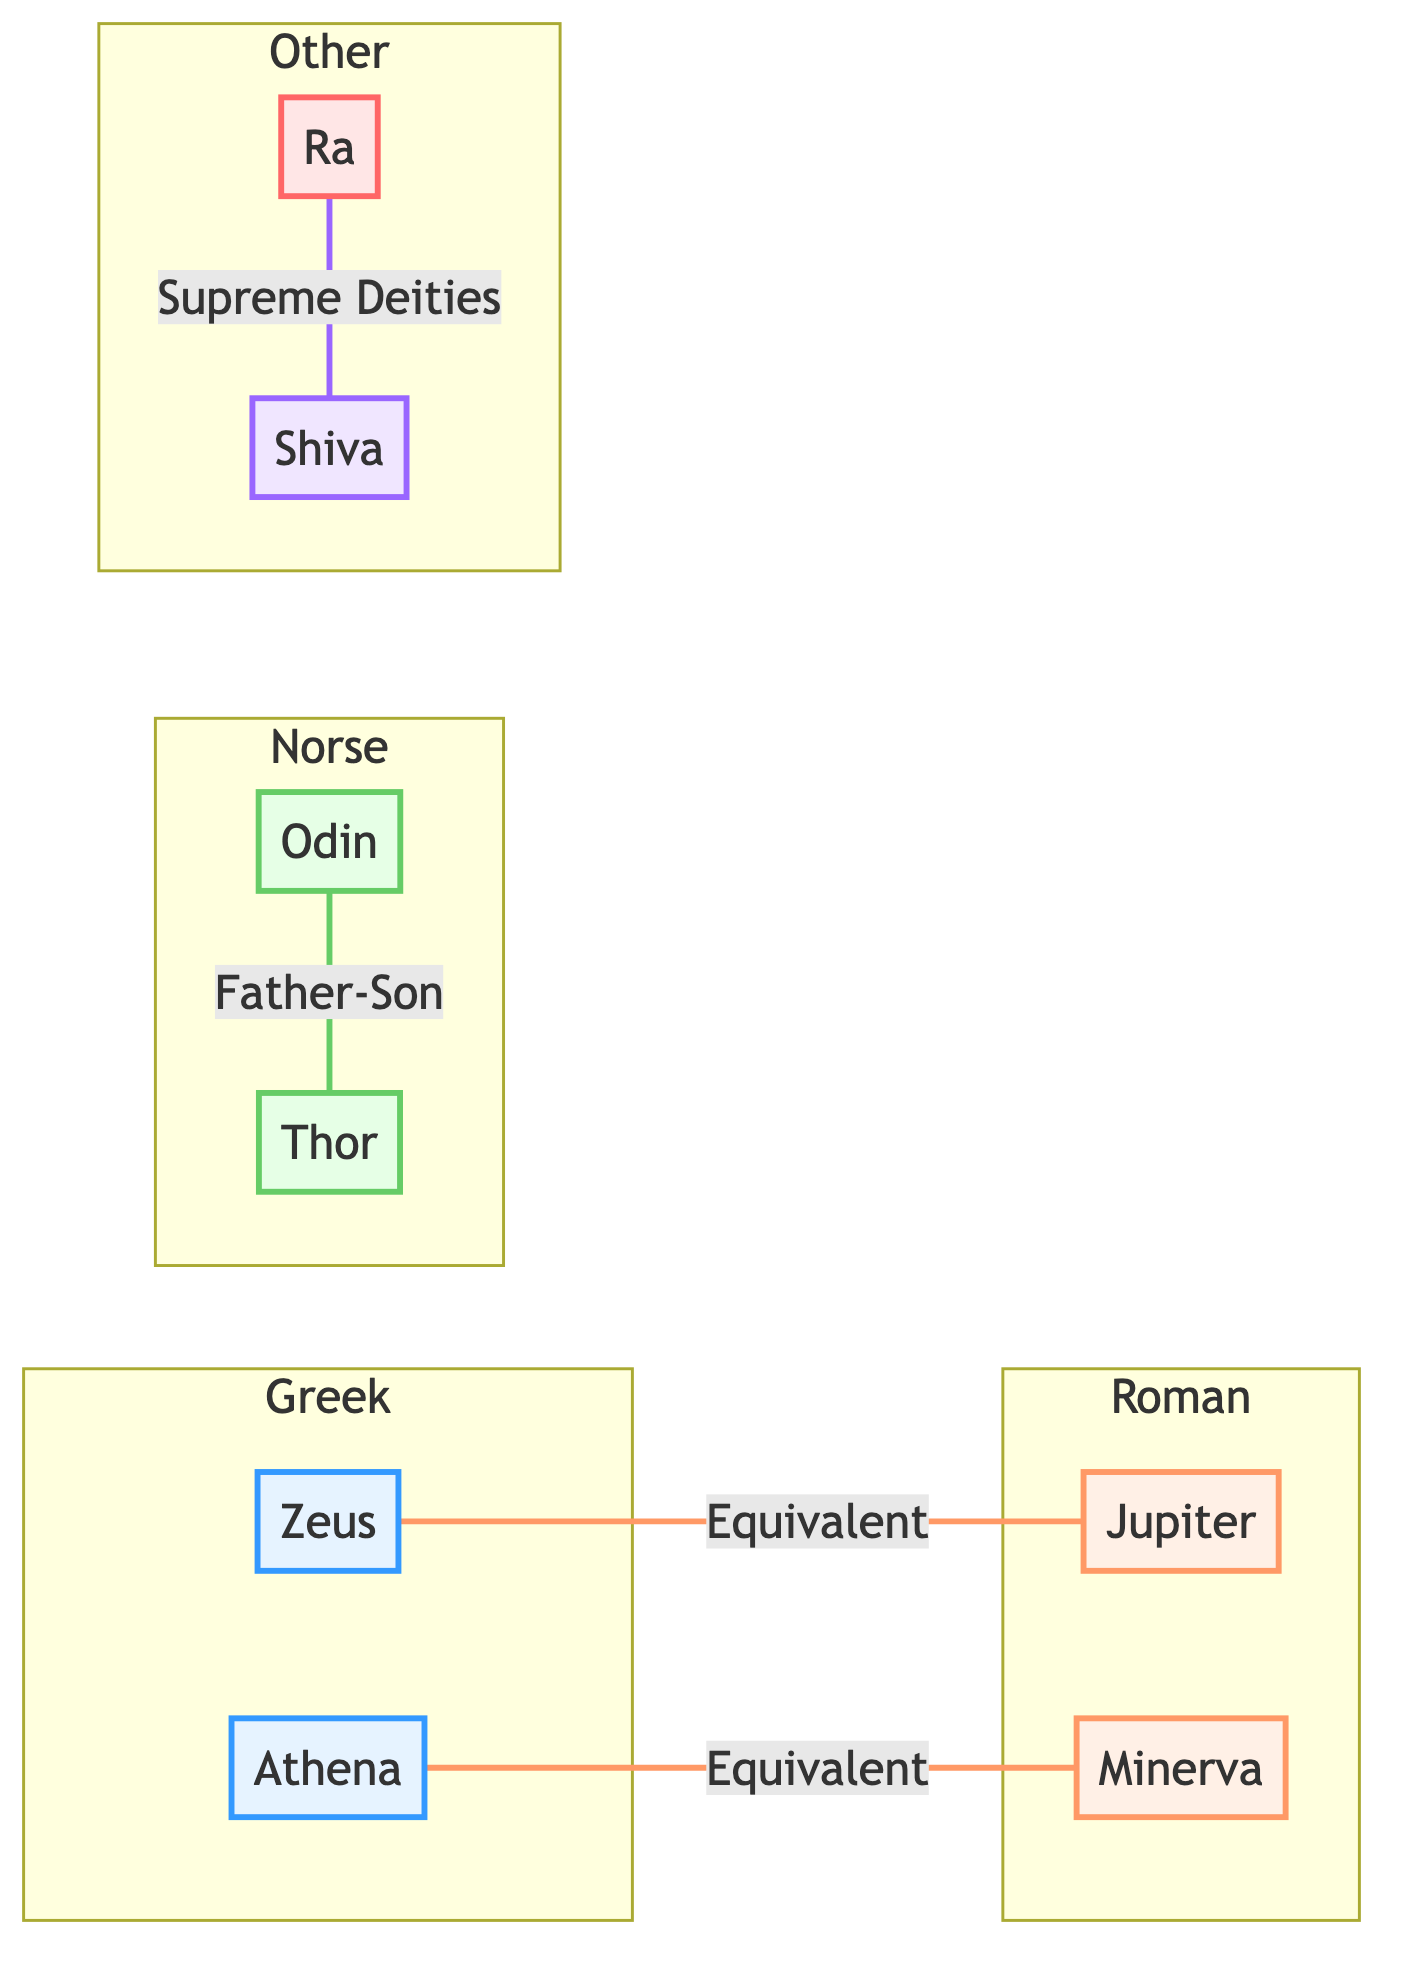What is the relationship between Zeus and Jupiter? The diagram shows an edge labeled "Equivalent" connecting Zeus (Greek Mythology) and Jupiter (Roman Mythology), indicating that they are considered equivalent figures in their respective mythologies.
Answer: Equivalent How many nodes are represented in the diagram? The diagram lists eight distinct mythological figures (nodes), specifically Zeus, Jupiter, Odin, Thor, Ra, Shiva, Athena, and Minerva. Counting these gives us a total of eight nodes.
Answer: 8 Which figures are classified under Norse Mythology? The diagram indicates that Odin and Thor are the nodes in the Norse category, as shown by their clustering and style definition in the "Norse" subgraph.
Answer: Odin, Thor What type of relationship exists between Odin and Thor? The diagram illustrates a "Father-Son" relationship between Odin and Thor, represented as an edge linking the two nodes with this specific label.
Answer: Father-Son How many relationships in the diagram are characterized as "Equivalent"? The diagram contains two relationships labeled as "Equivalent": one between Zeus and Jupiter, and another between Athena and Minerva. Thus, the count of these relationships is two.
Answer: 2 Which mythological figures are both revered as Supreme Deities? The diagram shows an edge connecting Ra (Egyptian Mythology) and Shiva (Hindu Mythology) with the label "Both revered as Supreme Deities," highlighting their shared status across these cultures.
Answer: Ra, Shiva What is the main defining characteristic of the Roman subgraph? The Roman subgraph includes the figures Jupiter and Minerva, and both are connected through their equivalent relationships with their Greek counterparts, signaling a strong equivalency theme in Roman mythology.
Answer: Equivalent relationships Which two figures have a father-son link? The diagram explicitly indicates that Odin and Thor are connected through a "Father-Son" relationship, making this relationship clear and direct between these two Norse figures.
Answer: Odin, Thor 